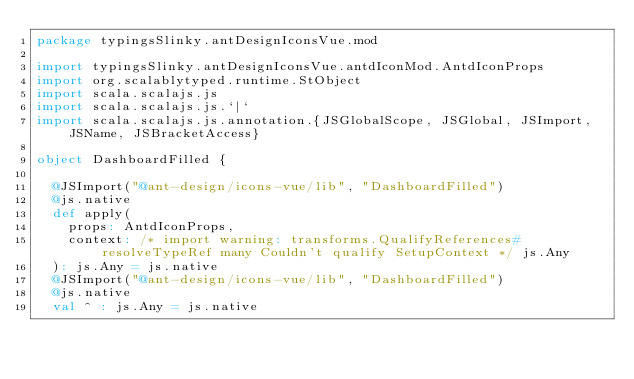Convert code to text. <code><loc_0><loc_0><loc_500><loc_500><_Scala_>package typingsSlinky.antDesignIconsVue.mod

import typingsSlinky.antDesignIconsVue.antdIconMod.AntdIconProps
import org.scalablytyped.runtime.StObject
import scala.scalajs.js
import scala.scalajs.js.`|`
import scala.scalajs.js.annotation.{JSGlobalScope, JSGlobal, JSImport, JSName, JSBracketAccess}

object DashboardFilled {
  
  @JSImport("@ant-design/icons-vue/lib", "DashboardFilled")
  @js.native
  def apply(
    props: AntdIconProps,
    context: /* import warning: transforms.QualifyReferences#resolveTypeRef many Couldn't qualify SetupContext */ js.Any
  ): js.Any = js.native
  @JSImport("@ant-design/icons-vue/lib", "DashboardFilled")
  @js.native
  val ^ : js.Any = js.native
  </code> 